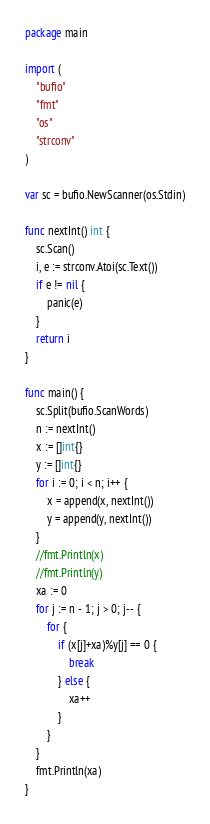<code> <loc_0><loc_0><loc_500><loc_500><_Go_>package main

import (
	"bufio"
	"fmt"
	"os"
	"strconv"
)

var sc = bufio.NewScanner(os.Stdin)

func nextInt() int {
	sc.Scan()
	i, e := strconv.Atoi(sc.Text())
	if e != nil {
		panic(e)
	}
	return i
}

func main() {
	sc.Split(bufio.ScanWords)
	n := nextInt()
	x := []int{}
	y := []int{}
	for i := 0; i < n; i++ {
		x = append(x, nextInt())
		y = append(y, nextInt())
	}
	//fmt.Println(x)
	//fmt.Println(y)
	xa := 0
	for j := n - 1; j > 0; j-- {
		for {
			if (x[j]+xa)%y[j] == 0 {
				break
			} else {
				xa++
			}
		}
	}
	fmt.Println(xa)
}
</code> 